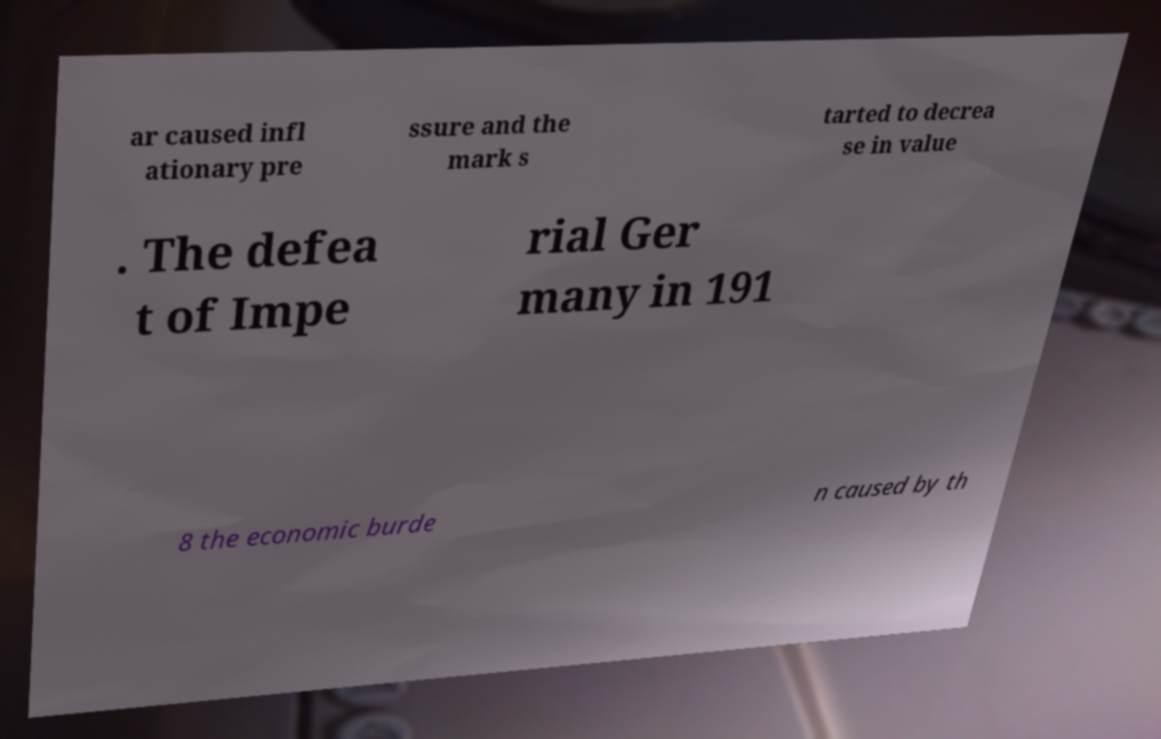Please identify and transcribe the text found in this image. ar caused infl ationary pre ssure and the mark s tarted to decrea se in value . The defea t of Impe rial Ger many in 191 8 the economic burde n caused by th 